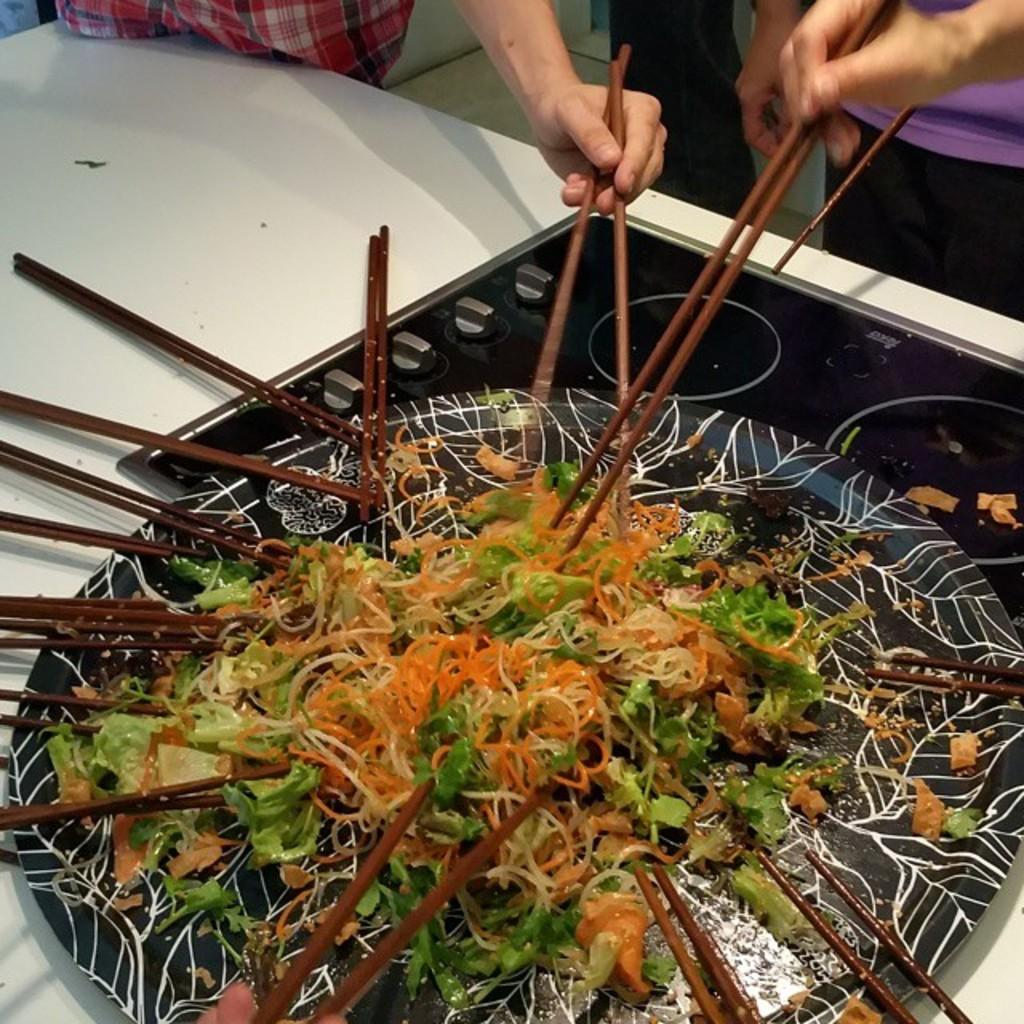What is on the plate in the image? There are noodles and vegetables on a plate. What utensils are present in the image? There are chopsticks present. Who is in the image? There are two men standing behind the plate. What are the men holding in their hands? The men are holding chopsticks in their hands. What type of sea creatures can be seen swimming in the image? There are no sea creatures present in the image; it features a plate of noodles and vegetables with chopsticks and two men holding chopsticks. Are there any slaves depicted in the image? There is no depiction of slavery or slaves in the image. 